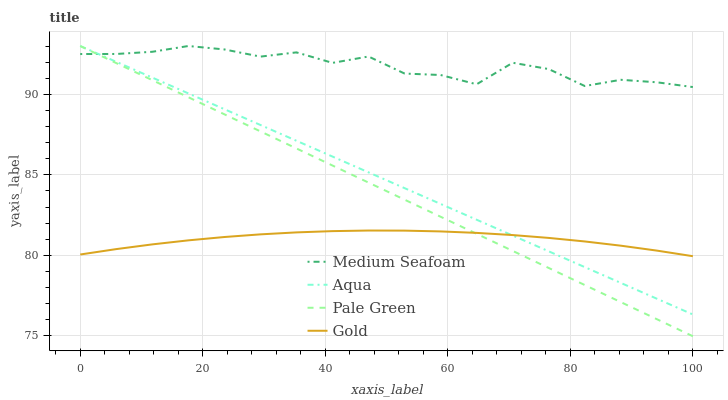Does Aqua have the minimum area under the curve?
Answer yes or no. No. Does Aqua have the maximum area under the curve?
Answer yes or no. No. Is Aqua the smoothest?
Answer yes or no. No. Is Aqua the roughest?
Answer yes or no. No. Does Aqua have the lowest value?
Answer yes or no. No. Does Gold have the highest value?
Answer yes or no. No. Is Gold less than Medium Seafoam?
Answer yes or no. Yes. Is Medium Seafoam greater than Gold?
Answer yes or no. Yes. Does Gold intersect Medium Seafoam?
Answer yes or no. No. 